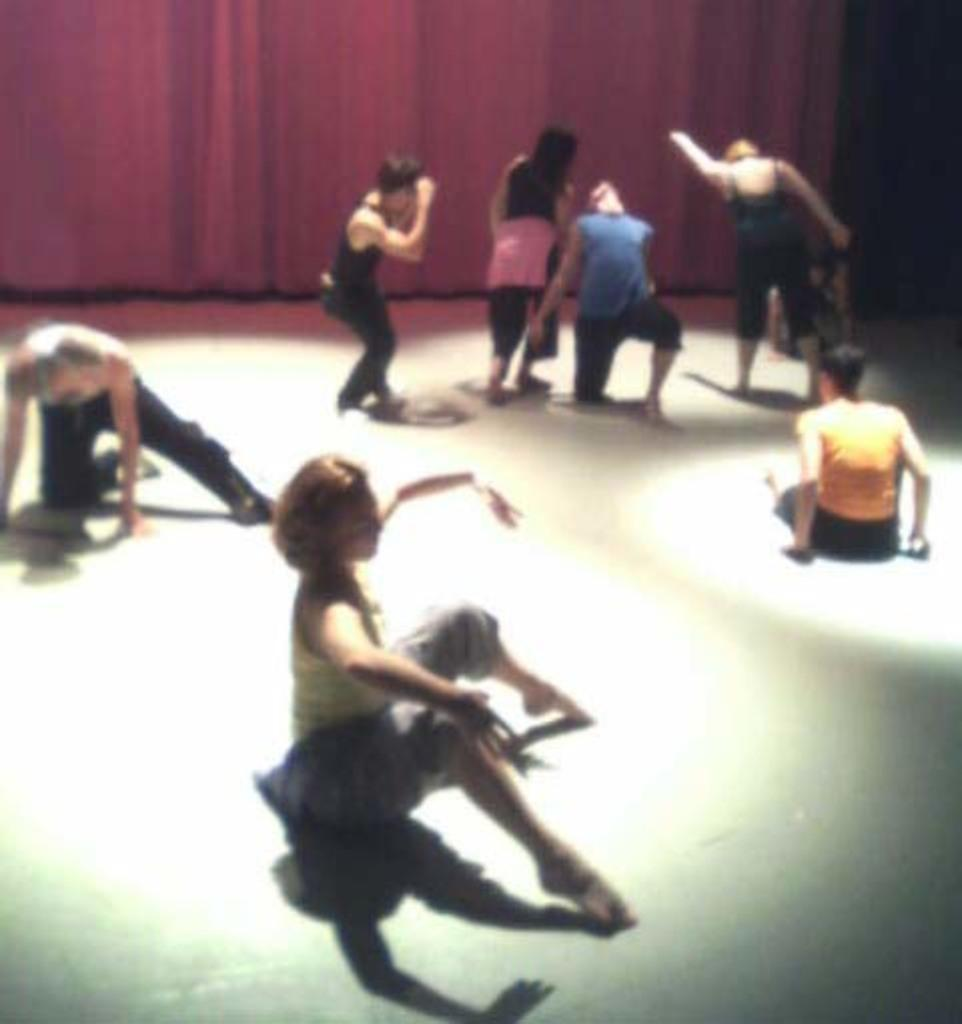What is the main feature of the image? There is a stage in the image. What are the people on the stage doing? There are persons sitting and standing on the stage. What can be seen in the background of the image? There is a pink-colored curtain in the background of the image. What type of offer is the beggar making in the image? There is no beggar present in the image, and therefore no offer can be made. What discovery was made by the persons on the stage in the image? There is no indication of a discovery being made by the persons on the stage in the image. 